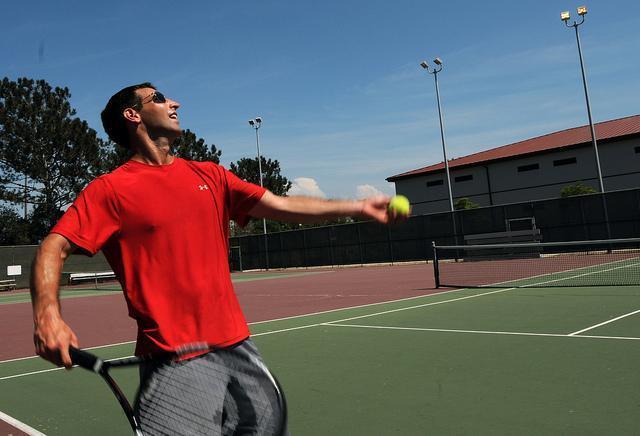How many tennis balls is he holding?
Give a very brief answer. 1. How many pairs of scissors in this photo?
Give a very brief answer. 0. 